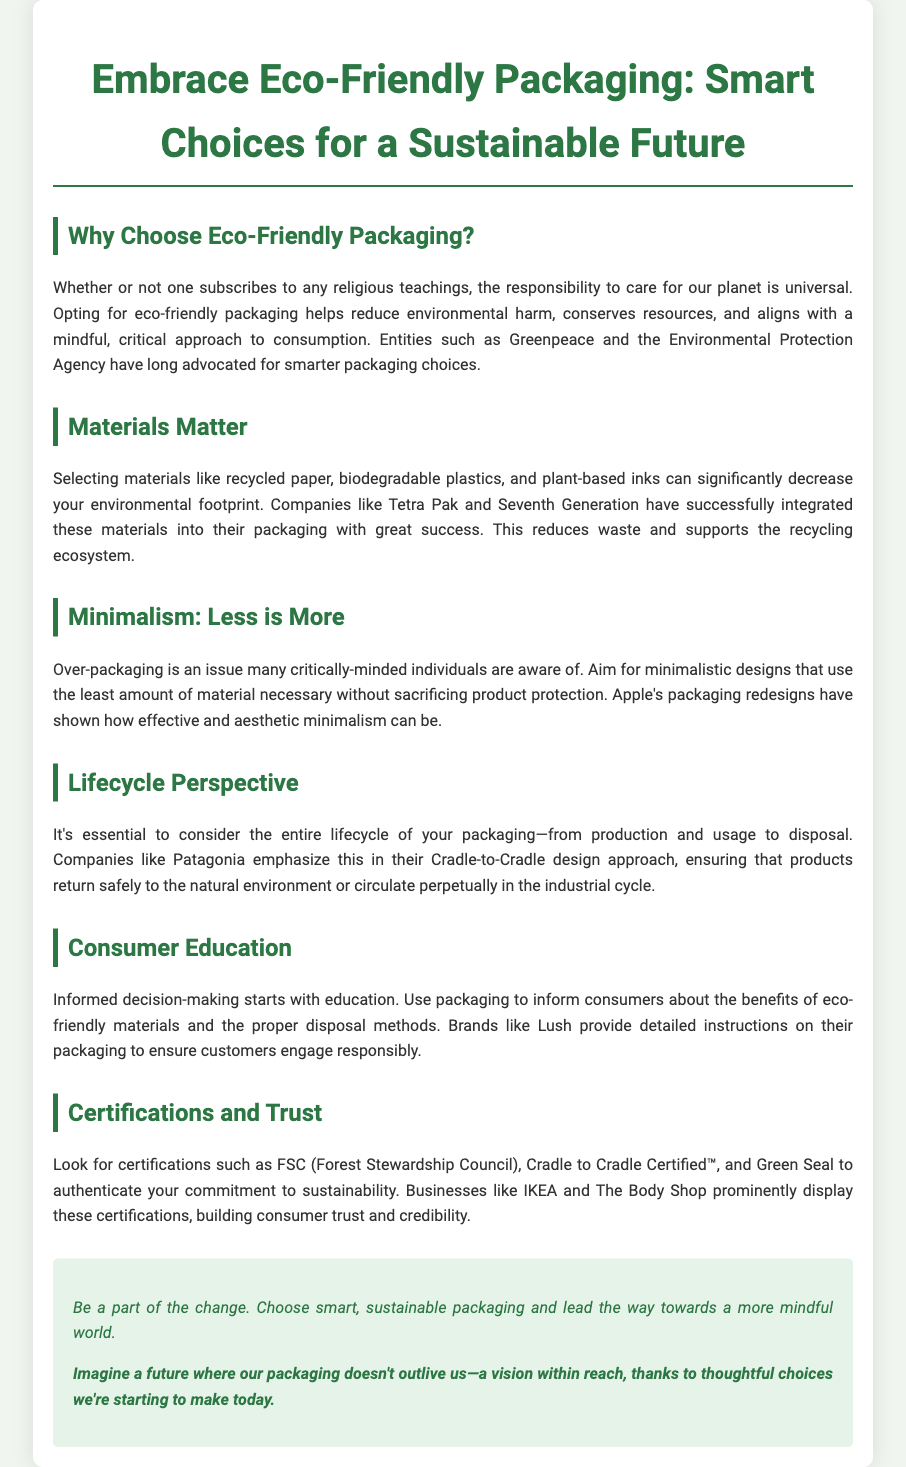What is the main purpose of eco-friendly packaging? The document states that the main purpose is to reduce environmental harm, conserve resources, and align with responsible consumption.
Answer: Reduce environmental harm Which companies are mentioned as examples of those using eco-friendly materials? The document references companies like Tetra Pak and Seventh Generation as examples that use recycled and biodegradable materials.
Answer: Tetra Pak and Seventh Generation What design approach is emphasized to combat over-packaging? The document highlights minimalistic designs as an effective approach to reduce the amount of material used.
Answer: Minimalism What lifecycle approach does Patagonia emphasize? The document mentions the Cradle-to-Cradle design approach to ensure packaging returns safely to the environment.
Answer: Cradle-to-Cradle Which certifications are recommended to authenticate sustainability? The document lists certifications such as FSC, Cradle to Cradle Certified™, and Green Seal.
Answer: FSC, Cradle to Cradle Certified™, and Green Seal What type of companies prominently display sustainability certifications? The document indicates that businesses like IKEA and The Body Shop display these certifications to build consumer trust.
Answer: IKEA and The Body Shop How does consumer education play a role in eco-friendly packaging? The document explains that informed decision-making starts with education and packaging can inform consumers about benefits and disposal methods.
Answer: Informed decision-making What is suggested as a benefit of properly informing consumers through packaging? The document states that brands like Lush provide detailed instructions to engage customers responsibly.
Answer: Engage customers responsibly 